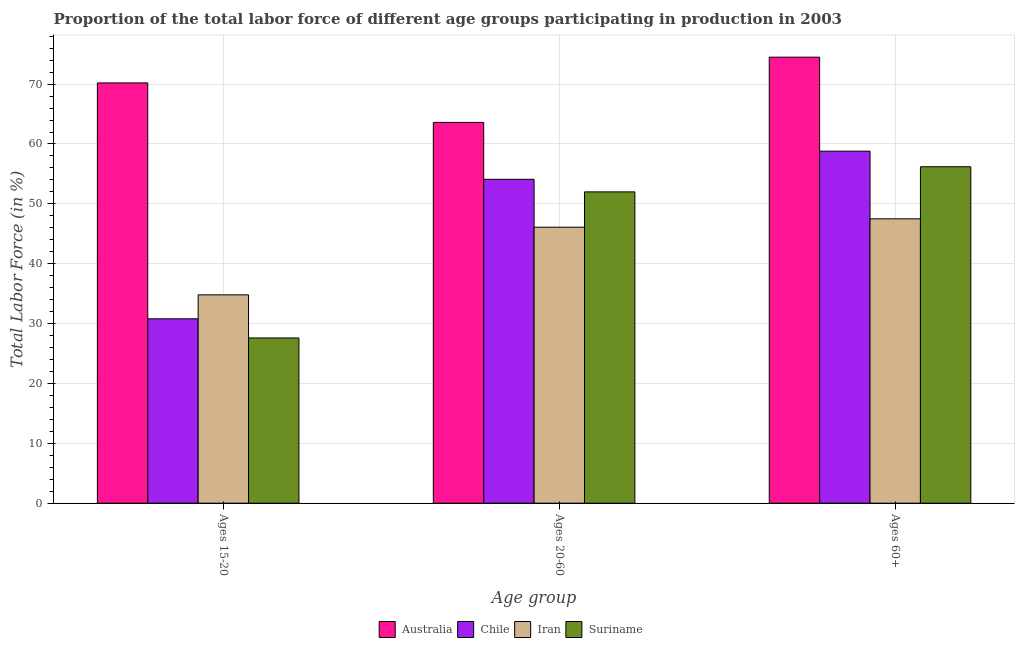How many groups of bars are there?
Make the answer very short. 3. Are the number of bars per tick equal to the number of legend labels?
Give a very brief answer. Yes. What is the label of the 2nd group of bars from the left?
Your answer should be compact. Ages 20-60. What is the percentage of labor force within the age group 20-60 in Iran?
Offer a terse response. 46.1. Across all countries, what is the maximum percentage of labor force within the age group 20-60?
Your answer should be very brief. 63.6. Across all countries, what is the minimum percentage of labor force above age 60?
Offer a very short reply. 47.5. In which country was the percentage of labor force within the age group 15-20 maximum?
Offer a terse response. Australia. In which country was the percentage of labor force within the age group 15-20 minimum?
Offer a very short reply. Suriname. What is the total percentage of labor force above age 60 in the graph?
Provide a succinct answer. 237. What is the difference between the percentage of labor force within the age group 20-60 in Iran and that in Australia?
Make the answer very short. -17.5. What is the difference between the percentage of labor force above age 60 in Chile and the percentage of labor force within the age group 15-20 in Suriname?
Ensure brevity in your answer.  31.2. What is the average percentage of labor force within the age group 20-60 per country?
Ensure brevity in your answer.  53.95. What is the difference between the percentage of labor force within the age group 15-20 and percentage of labor force above age 60 in Australia?
Make the answer very short. -4.3. What is the ratio of the percentage of labor force within the age group 15-20 in Australia to that in Chile?
Keep it short and to the point. 2.28. Is the percentage of labor force within the age group 15-20 in Australia less than that in Suriname?
Provide a short and direct response. No. Is the difference between the percentage of labor force above age 60 in Chile and Suriname greater than the difference between the percentage of labor force within the age group 20-60 in Chile and Suriname?
Make the answer very short. Yes. What is the difference between the highest and the second highest percentage of labor force above age 60?
Provide a succinct answer. 15.7. What is the difference between the highest and the lowest percentage of labor force within the age group 20-60?
Your response must be concise. 17.5. Is the sum of the percentage of labor force within the age group 15-20 in Australia and Chile greater than the maximum percentage of labor force within the age group 20-60 across all countries?
Offer a very short reply. Yes. What does the 4th bar from the left in Ages 20-60 represents?
Ensure brevity in your answer.  Suriname. What does the 2nd bar from the right in Ages 15-20 represents?
Offer a terse response. Iran. Does the graph contain any zero values?
Your response must be concise. No. Does the graph contain grids?
Offer a terse response. Yes. Where does the legend appear in the graph?
Your answer should be very brief. Bottom center. How many legend labels are there?
Your answer should be compact. 4. What is the title of the graph?
Provide a succinct answer. Proportion of the total labor force of different age groups participating in production in 2003. Does "Bahrain" appear as one of the legend labels in the graph?
Offer a terse response. No. What is the label or title of the X-axis?
Your answer should be very brief. Age group. What is the label or title of the Y-axis?
Your answer should be compact. Total Labor Force (in %). What is the Total Labor Force (in %) of Australia in Ages 15-20?
Give a very brief answer. 70.2. What is the Total Labor Force (in %) in Chile in Ages 15-20?
Your answer should be compact. 30.8. What is the Total Labor Force (in %) in Iran in Ages 15-20?
Provide a succinct answer. 34.8. What is the Total Labor Force (in %) of Suriname in Ages 15-20?
Provide a short and direct response. 27.6. What is the Total Labor Force (in %) in Australia in Ages 20-60?
Ensure brevity in your answer.  63.6. What is the Total Labor Force (in %) in Chile in Ages 20-60?
Offer a terse response. 54.1. What is the Total Labor Force (in %) in Iran in Ages 20-60?
Give a very brief answer. 46.1. What is the Total Labor Force (in %) of Suriname in Ages 20-60?
Give a very brief answer. 52. What is the Total Labor Force (in %) in Australia in Ages 60+?
Offer a terse response. 74.5. What is the Total Labor Force (in %) of Chile in Ages 60+?
Your response must be concise. 58.8. What is the Total Labor Force (in %) in Iran in Ages 60+?
Ensure brevity in your answer.  47.5. What is the Total Labor Force (in %) in Suriname in Ages 60+?
Ensure brevity in your answer.  56.2. Across all Age group, what is the maximum Total Labor Force (in %) in Australia?
Your response must be concise. 74.5. Across all Age group, what is the maximum Total Labor Force (in %) of Chile?
Ensure brevity in your answer.  58.8. Across all Age group, what is the maximum Total Labor Force (in %) in Iran?
Give a very brief answer. 47.5. Across all Age group, what is the maximum Total Labor Force (in %) of Suriname?
Your answer should be very brief. 56.2. Across all Age group, what is the minimum Total Labor Force (in %) in Australia?
Your response must be concise. 63.6. Across all Age group, what is the minimum Total Labor Force (in %) of Chile?
Give a very brief answer. 30.8. Across all Age group, what is the minimum Total Labor Force (in %) in Iran?
Make the answer very short. 34.8. Across all Age group, what is the minimum Total Labor Force (in %) of Suriname?
Give a very brief answer. 27.6. What is the total Total Labor Force (in %) in Australia in the graph?
Your answer should be very brief. 208.3. What is the total Total Labor Force (in %) of Chile in the graph?
Offer a terse response. 143.7. What is the total Total Labor Force (in %) of Iran in the graph?
Make the answer very short. 128.4. What is the total Total Labor Force (in %) of Suriname in the graph?
Ensure brevity in your answer.  135.8. What is the difference between the Total Labor Force (in %) in Australia in Ages 15-20 and that in Ages 20-60?
Make the answer very short. 6.6. What is the difference between the Total Labor Force (in %) of Chile in Ages 15-20 and that in Ages 20-60?
Give a very brief answer. -23.3. What is the difference between the Total Labor Force (in %) of Suriname in Ages 15-20 and that in Ages 20-60?
Provide a short and direct response. -24.4. What is the difference between the Total Labor Force (in %) of Australia in Ages 15-20 and that in Ages 60+?
Ensure brevity in your answer.  -4.3. What is the difference between the Total Labor Force (in %) of Suriname in Ages 15-20 and that in Ages 60+?
Ensure brevity in your answer.  -28.6. What is the difference between the Total Labor Force (in %) of Australia in Ages 20-60 and that in Ages 60+?
Give a very brief answer. -10.9. What is the difference between the Total Labor Force (in %) in Suriname in Ages 20-60 and that in Ages 60+?
Provide a succinct answer. -4.2. What is the difference between the Total Labor Force (in %) of Australia in Ages 15-20 and the Total Labor Force (in %) of Iran in Ages 20-60?
Your answer should be compact. 24.1. What is the difference between the Total Labor Force (in %) in Chile in Ages 15-20 and the Total Labor Force (in %) in Iran in Ages 20-60?
Your answer should be compact. -15.3. What is the difference between the Total Labor Force (in %) in Chile in Ages 15-20 and the Total Labor Force (in %) in Suriname in Ages 20-60?
Your answer should be compact. -21.2. What is the difference between the Total Labor Force (in %) of Iran in Ages 15-20 and the Total Labor Force (in %) of Suriname in Ages 20-60?
Your response must be concise. -17.2. What is the difference between the Total Labor Force (in %) in Australia in Ages 15-20 and the Total Labor Force (in %) in Iran in Ages 60+?
Give a very brief answer. 22.7. What is the difference between the Total Labor Force (in %) of Chile in Ages 15-20 and the Total Labor Force (in %) of Iran in Ages 60+?
Your answer should be compact. -16.7. What is the difference between the Total Labor Force (in %) in Chile in Ages 15-20 and the Total Labor Force (in %) in Suriname in Ages 60+?
Make the answer very short. -25.4. What is the difference between the Total Labor Force (in %) of Iran in Ages 15-20 and the Total Labor Force (in %) of Suriname in Ages 60+?
Keep it short and to the point. -21.4. What is the difference between the Total Labor Force (in %) in Australia in Ages 20-60 and the Total Labor Force (in %) in Iran in Ages 60+?
Your answer should be very brief. 16.1. What is the difference between the Total Labor Force (in %) in Chile in Ages 20-60 and the Total Labor Force (in %) in Suriname in Ages 60+?
Make the answer very short. -2.1. What is the difference between the Total Labor Force (in %) in Iran in Ages 20-60 and the Total Labor Force (in %) in Suriname in Ages 60+?
Offer a terse response. -10.1. What is the average Total Labor Force (in %) in Australia per Age group?
Keep it short and to the point. 69.43. What is the average Total Labor Force (in %) in Chile per Age group?
Make the answer very short. 47.9. What is the average Total Labor Force (in %) of Iran per Age group?
Offer a terse response. 42.8. What is the average Total Labor Force (in %) in Suriname per Age group?
Provide a succinct answer. 45.27. What is the difference between the Total Labor Force (in %) of Australia and Total Labor Force (in %) of Chile in Ages 15-20?
Your response must be concise. 39.4. What is the difference between the Total Labor Force (in %) of Australia and Total Labor Force (in %) of Iran in Ages 15-20?
Provide a short and direct response. 35.4. What is the difference between the Total Labor Force (in %) of Australia and Total Labor Force (in %) of Suriname in Ages 15-20?
Make the answer very short. 42.6. What is the difference between the Total Labor Force (in %) of Australia and Total Labor Force (in %) of Iran in Ages 20-60?
Give a very brief answer. 17.5. What is the difference between the Total Labor Force (in %) in Australia and Total Labor Force (in %) in Suriname in Ages 20-60?
Make the answer very short. 11.6. What is the difference between the Total Labor Force (in %) in Chile and Total Labor Force (in %) in Iran in Ages 20-60?
Provide a short and direct response. 8. What is the difference between the Total Labor Force (in %) in Iran and Total Labor Force (in %) in Suriname in Ages 20-60?
Ensure brevity in your answer.  -5.9. What is the difference between the Total Labor Force (in %) in Australia and Total Labor Force (in %) in Iran in Ages 60+?
Keep it short and to the point. 27. What is the difference between the Total Labor Force (in %) in Chile and Total Labor Force (in %) in Iran in Ages 60+?
Your response must be concise. 11.3. What is the ratio of the Total Labor Force (in %) in Australia in Ages 15-20 to that in Ages 20-60?
Offer a terse response. 1.1. What is the ratio of the Total Labor Force (in %) of Chile in Ages 15-20 to that in Ages 20-60?
Keep it short and to the point. 0.57. What is the ratio of the Total Labor Force (in %) of Iran in Ages 15-20 to that in Ages 20-60?
Ensure brevity in your answer.  0.75. What is the ratio of the Total Labor Force (in %) in Suriname in Ages 15-20 to that in Ages 20-60?
Provide a succinct answer. 0.53. What is the ratio of the Total Labor Force (in %) of Australia in Ages 15-20 to that in Ages 60+?
Offer a terse response. 0.94. What is the ratio of the Total Labor Force (in %) in Chile in Ages 15-20 to that in Ages 60+?
Give a very brief answer. 0.52. What is the ratio of the Total Labor Force (in %) in Iran in Ages 15-20 to that in Ages 60+?
Make the answer very short. 0.73. What is the ratio of the Total Labor Force (in %) in Suriname in Ages 15-20 to that in Ages 60+?
Give a very brief answer. 0.49. What is the ratio of the Total Labor Force (in %) in Australia in Ages 20-60 to that in Ages 60+?
Make the answer very short. 0.85. What is the ratio of the Total Labor Force (in %) of Chile in Ages 20-60 to that in Ages 60+?
Your answer should be very brief. 0.92. What is the ratio of the Total Labor Force (in %) of Iran in Ages 20-60 to that in Ages 60+?
Ensure brevity in your answer.  0.97. What is the ratio of the Total Labor Force (in %) in Suriname in Ages 20-60 to that in Ages 60+?
Provide a short and direct response. 0.93. What is the difference between the highest and the second highest Total Labor Force (in %) in Chile?
Provide a short and direct response. 4.7. What is the difference between the highest and the second highest Total Labor Force (in %) of Iran?
Your answer should be compact. 1.4. What is the difference between the highest and the lowest Total Labor Force (in %) of Australia?
Offer a very short reply. 10.9. What is the difference between the highest and the lowest Total Labor Force (in %) in Suriname?
Keep it short and to the point. 28.6. 